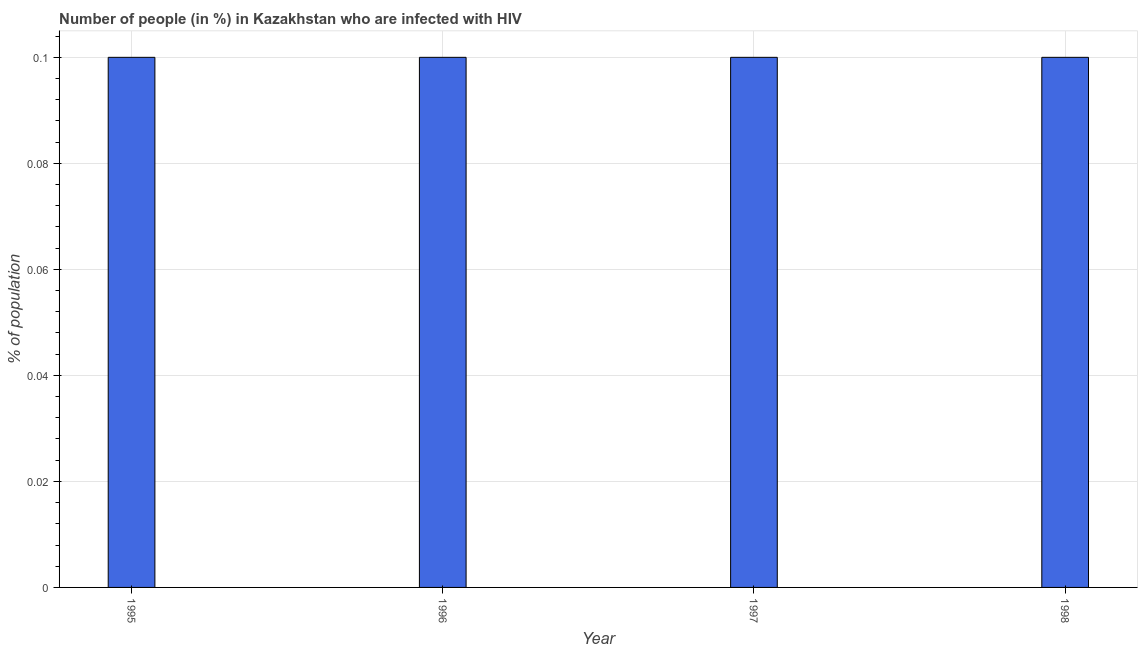Does the graph contain any zero values?
Your answer should be compact. No. Does the graph contain grids?
Offer a terse response. Yes. What is the title of the graph?
Keep it short and to the point. Number of people (in %) in Kazakhstan who are infected with HIV. What is the label or title of the Y-axis?
Offer a terse response. % of population. Across all years, what is the maximum number of people infected with hiv?
Keep it short and to the point. 0.1. In which year was the number of people infected with hiv minimum?
Keep it short and to the point. 1995. What is the difference between the number of people infected with hiv in 1996 and 1997?
Give a very brief answer. 0. What is the median number of people infected with hiv?
Your answer should be compact. 0.1. What is the ratio of the number of people infected with hiv in 1996 to that in 1997?
Ensure brevity in your answer.  1. Is the difference between the number of people infected with hiv in 1995 and 1996 greater than the difference between any two years?
Offer a terse response. Yes. What is the difference between the highest and the second highest number of people infected with hiv?
Ensure brevity in your answer.  0. What is the difference between the highest and the lowest number of people infected with hiv?
Give a very brief answer. 0. Are all the bars in the graph horizontal?
Offer a terse response. No. How many years are there in the graph?
Offer a very short reply. 4. Are the values on the major ticks of Y-axis written in scientific E-notation?
Offer a terse response. No. What is the % of population in 1997?
Provide a succinct answer. 0.1. What is the % of population in 1998?
Offer a terse response. 0.1. What is the difference between the % of population in 1995 and 1997?
Your answer should be very brief. 0. What is the difference between the % of population in 1996 and 1998?
Keep it short and to the point. 0. What is the ratio of the % of population in 1995 to that in 1997?
Your response must be concise. 1. What is the ratio of the % of population in 1995 to that in 1998?
Offer a very short reply. 1. What is the ratio of the % of population in 1996 to that in 1997?
Provide a succinct answer. 1. 